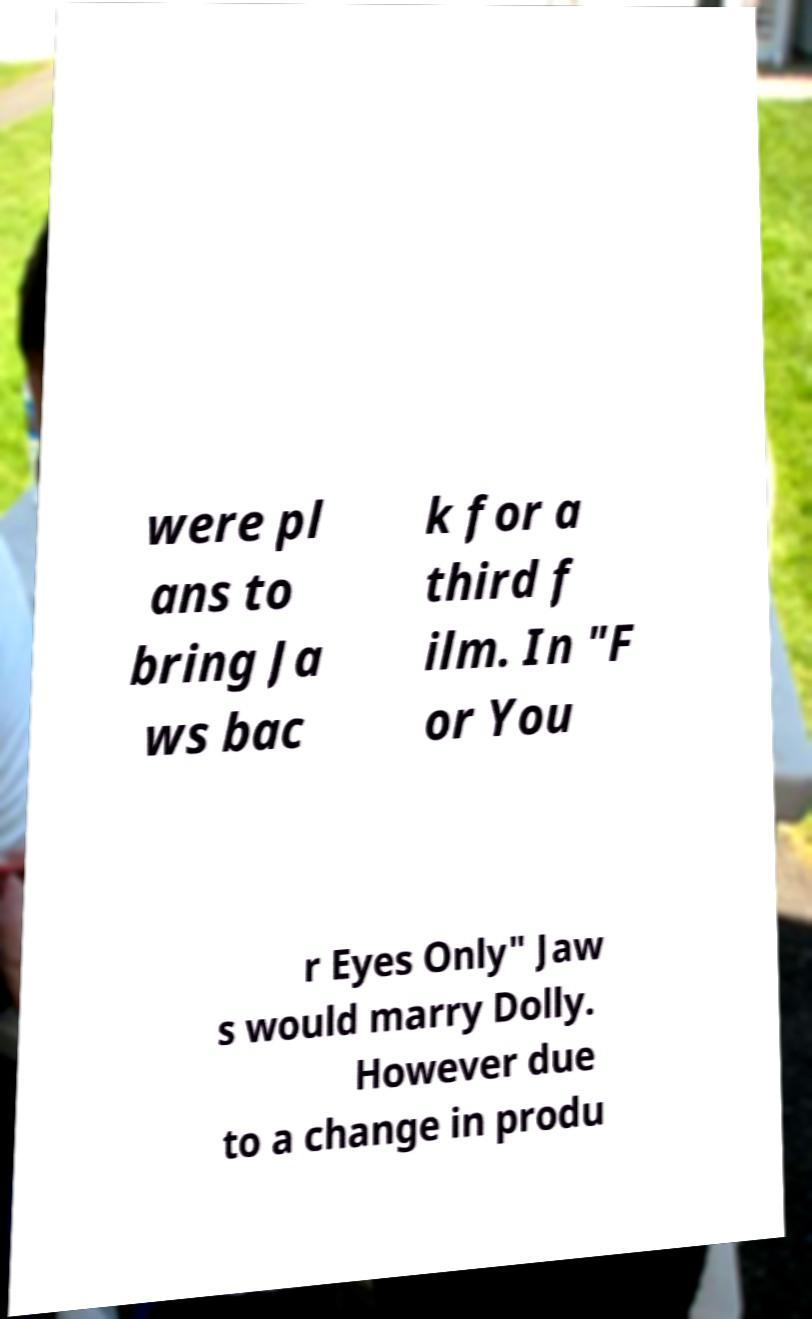Can you read and provide the text displayed in the image?This photo seems to have some interesting text. Can you extract and type it out for me? were pl ans to bring Ja ws bac k for a third f ilm. In "F or You r Eyes Only" Jaw s would marry Dolly. However due to a change in produ 